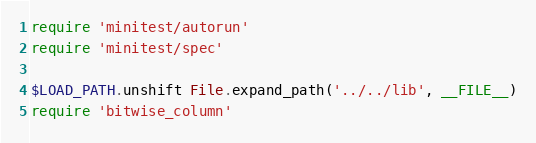<code> <loc_0><loc_0><loc_500><loc_500><_Ruby_>require 'minitest/autorun'
require 'minitest/spec'

$LOAD_PATH.unshift File.expand_path('../../lib', __FILE__)
require 'bitwise_column'
</code> 